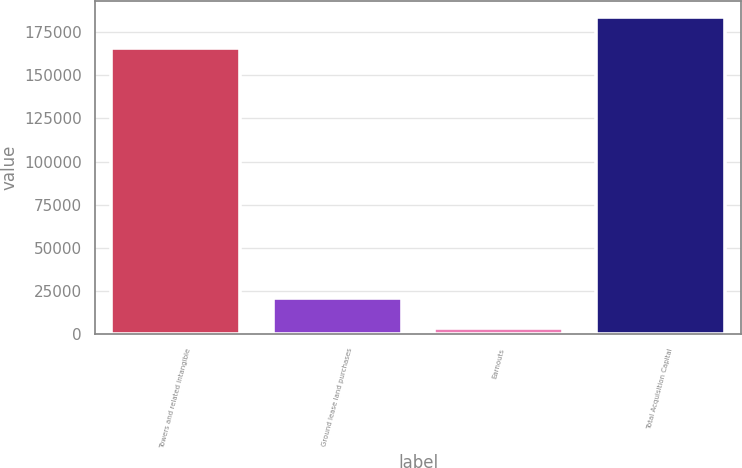<chart> <loc_0><loc_0><loc_500><loc_500><bar_chart><fcel>Towers and related intangible<fcel>Ground lease land purchases<fcel>Earnouts<fcel>Total Acquisition Capital<nl><fcel>165844<fcel>21119.1<fcel>3377<fcel>183586<nl></chart> 